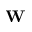Convert formula to latex. <formula><loc_0><loc_0><loc_500><loc_500>W</formula> 